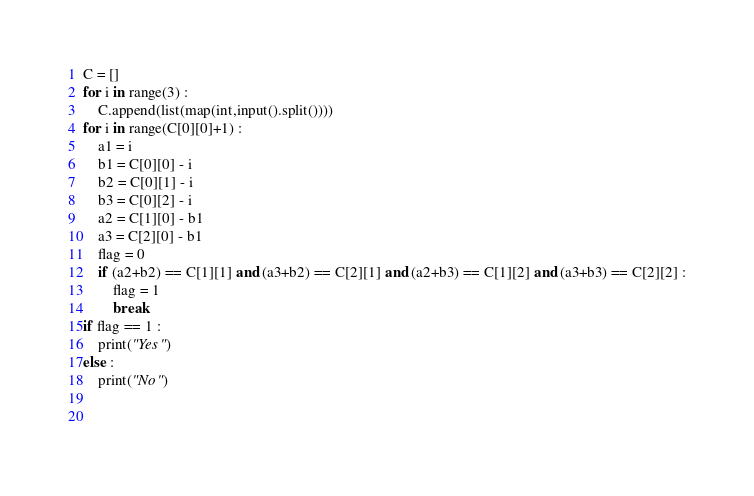<code> <loc_0><loc_0><loc_500><loc_500><_Python_>C = []
for i in range(3) :
    C.append(list(map(int,input().split())))
for i in range(C[0][0]+1) :
    a1 = i
    b1 = C[0][0] - i
    b2 = C[0][1] - i
    b3 = C[0][2] - i
    a2 = C[1][0] - b1
    a3 = C[2][0] - b1
    flag = 0
    if (a2+b2) == C[1][1] and (a3+b2) == C[2][1] and (a2+b3) == C[1][2] and (a3+b3) == C[2][2] :
        flag = 1
        break
if flag == 1 :
    print("Yes")
else :
    print("No")
    
    </code> 